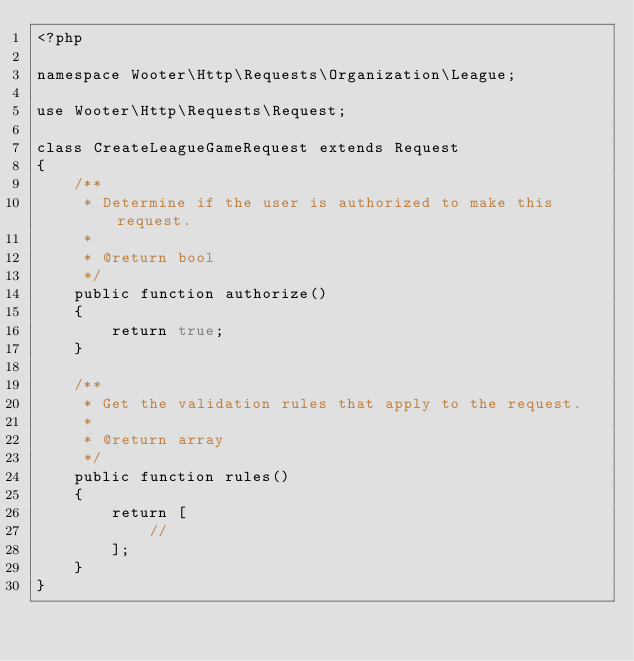<code> <loc_0><loc_0><loc_500><loc_500><_PHP_><?php

namespace Wooter\Http\Requests\Organization\League;

use Wooter\Http\Requests\Request;

class CreateLeagueGameRequest extends Request
{
    /**
     * Determine if the user is authorized to make this request.
     *
     * @return bool
     */
    public function authorize()
    {
        return true;
    }

    /**
     * Get the validation rules that apply to the request.
     *
     * @return array
     */
    public function rules()
    {
        return [
            //
        ];
    }
}


</code> 